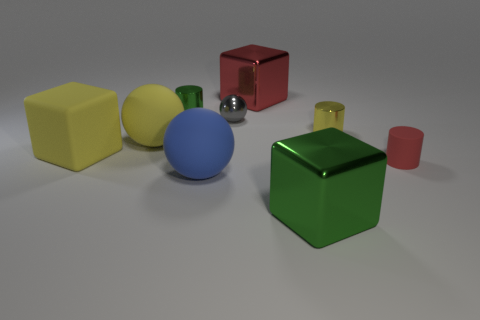What is the mood or atmosphere conveyed by the arrangement of objects? The mood conveyed by the image is one of order and simplicity. The arrangement of uniformly shaped objects against a neutral background creates a calm and balanced atmosphere, potentially used to explore basic concepts of geometry and color in a learning environment. 